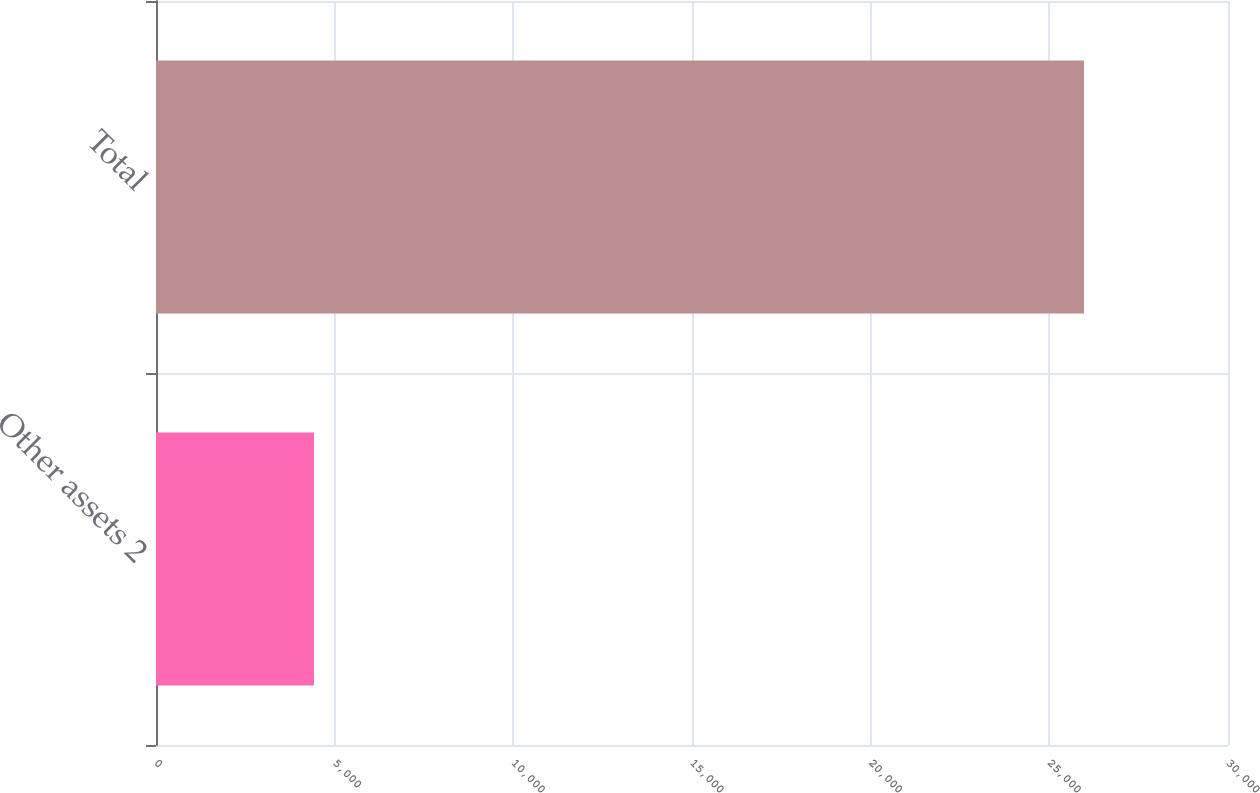Convert chart to OTSL. <chart><loc_0><loc_0><loc_500><loc_500><bar_chart><fcel>Other assets 2<fcel>Total<nl><fcel>4420<fcel>25969<nl></chart> 